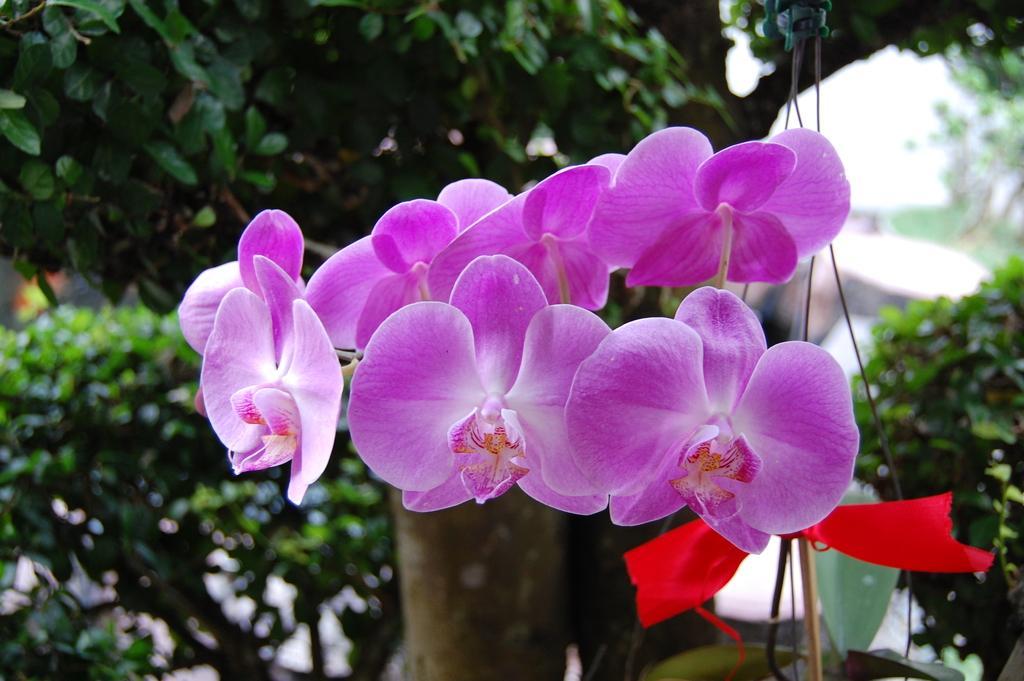Describe this image in one or two sentences. In this image we can see some flowers and a ribbon on the right side. On the backside we can see some leaves of a tree. 